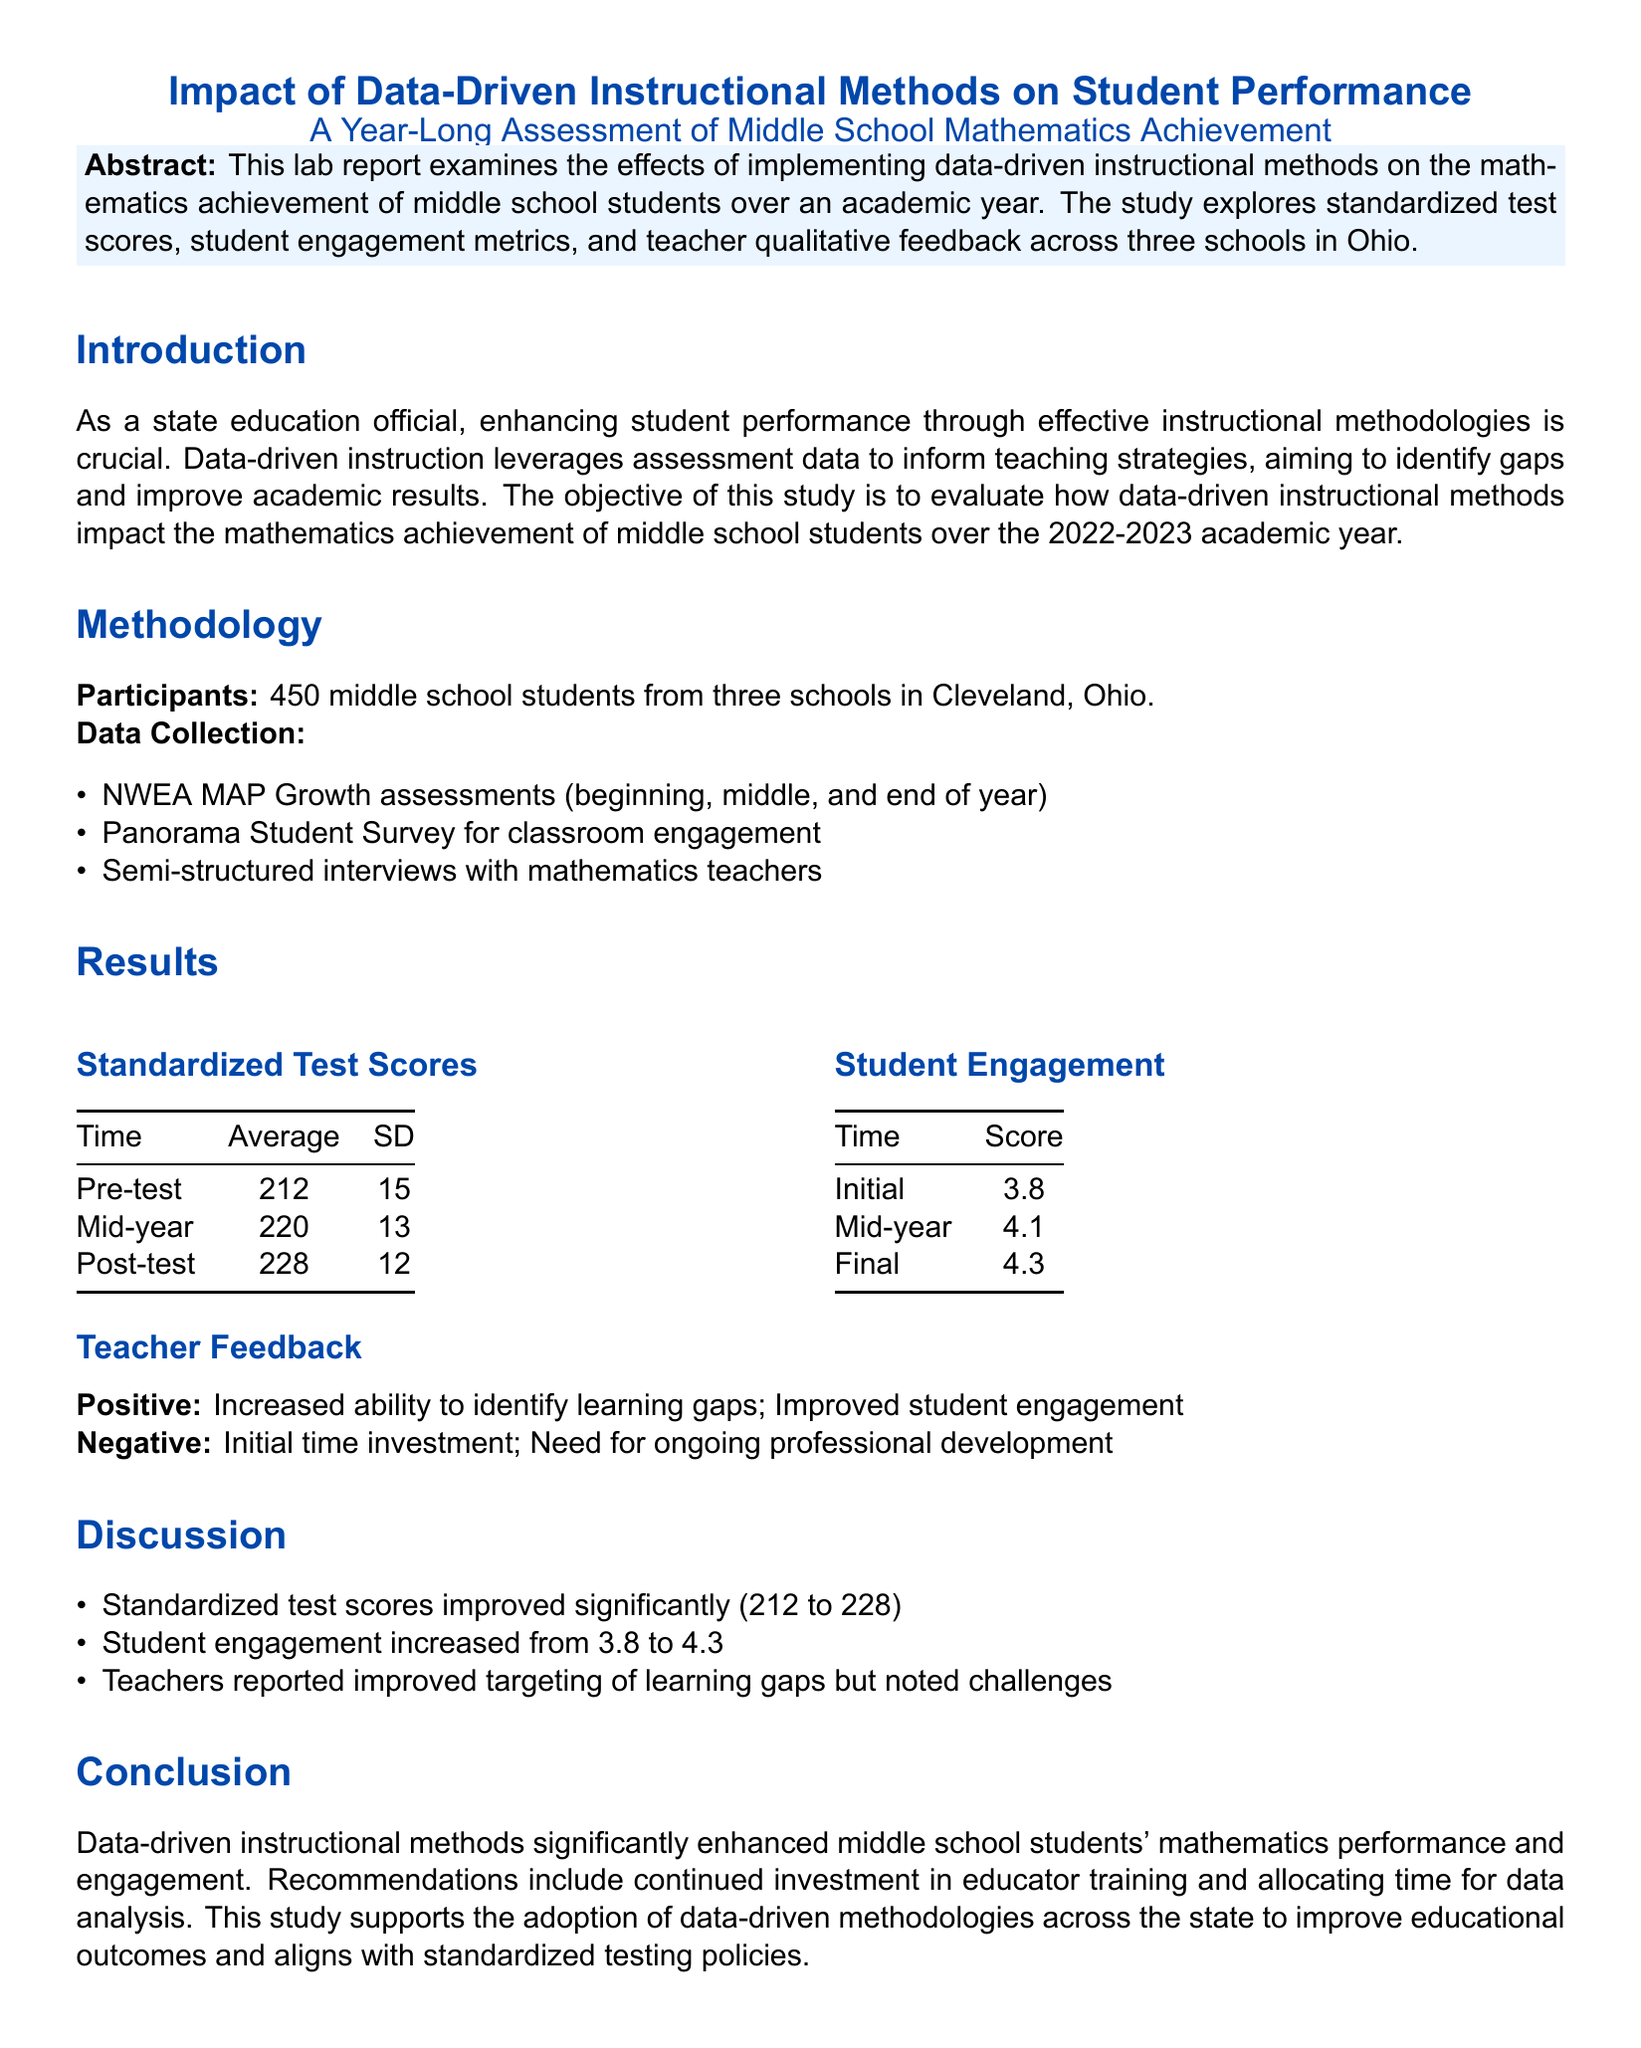What was the average score on the pre-test? The average score on the pre-test, as shown in the results, is 212.
Answer: 212 What was the final student engagement score? The final student engagement score is presented in the results, and it is 4.3.
Answer: 4.3 How many students participated in the study? The number of participants stated in the methodology section is 450 middle school students.
Answer: 450 What significant trend is observed in standardized test scores over the study period? The standardized test scores increased from the pre-test to the post-test, indicating improvement.
Answer: Improvement What challenge did teachers report regarding data-driven instructional methods? Teachers noted the challenge of initial time investment as a negative aspect.
Answer: Initial time investment What type of assessments were used for data collection? NWEA MAP Growth assessments were used for data collection.
Answer: NWEA MAP Growth assessments What additional recommendation is mentioned in the conclusion? The conclusion recommends continued investment in educator training.
Answer: Continued investment in educator training What is the location of the schools involved in the study? The schools involved in the study are located in Cleveland, Ohio.
Answer: Cleveland, Ohio What qualitative data was collected from teachers? Semi-structured interviews were conducted with mathematics teachers.
Answer: Semi-structured interviews 